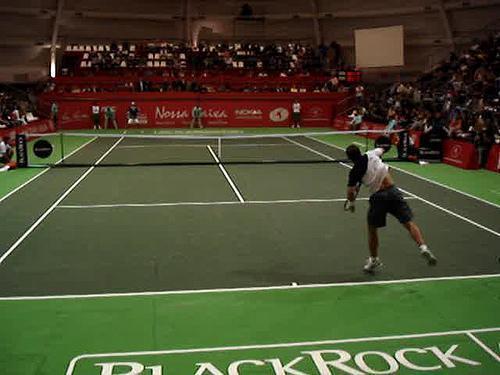What type of tennis swing is the main on the bottom of the court in the middle of?
Indicate the correct response and explain using: 'Answer: answer
Rationale: rationale.'
Options: Serve, backhand, drop shot, forearm. Answer: serve.
Rationale: The tennis swing is a serve. 